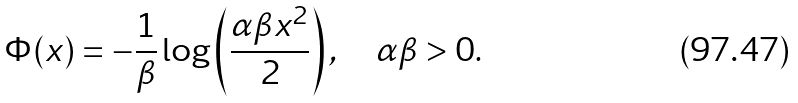Convert formula to latex. <formula><loc_0><loc_0><loc_500><loc_500>\Phi ( x ) = - \frac { 1 } { \beta } \log \left ( \frac { \alpha \beta x ^ { 2 } } { 2 } \right ) , \quad \alpha \beta > 0 .</formula> 